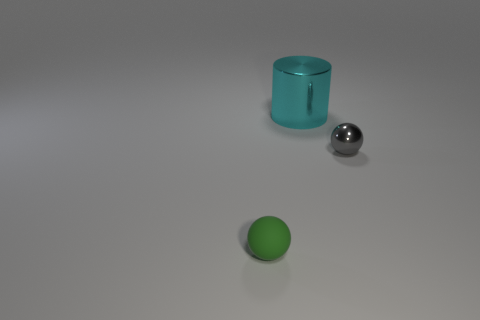How many rubber things are large balls or cyan things? 0 